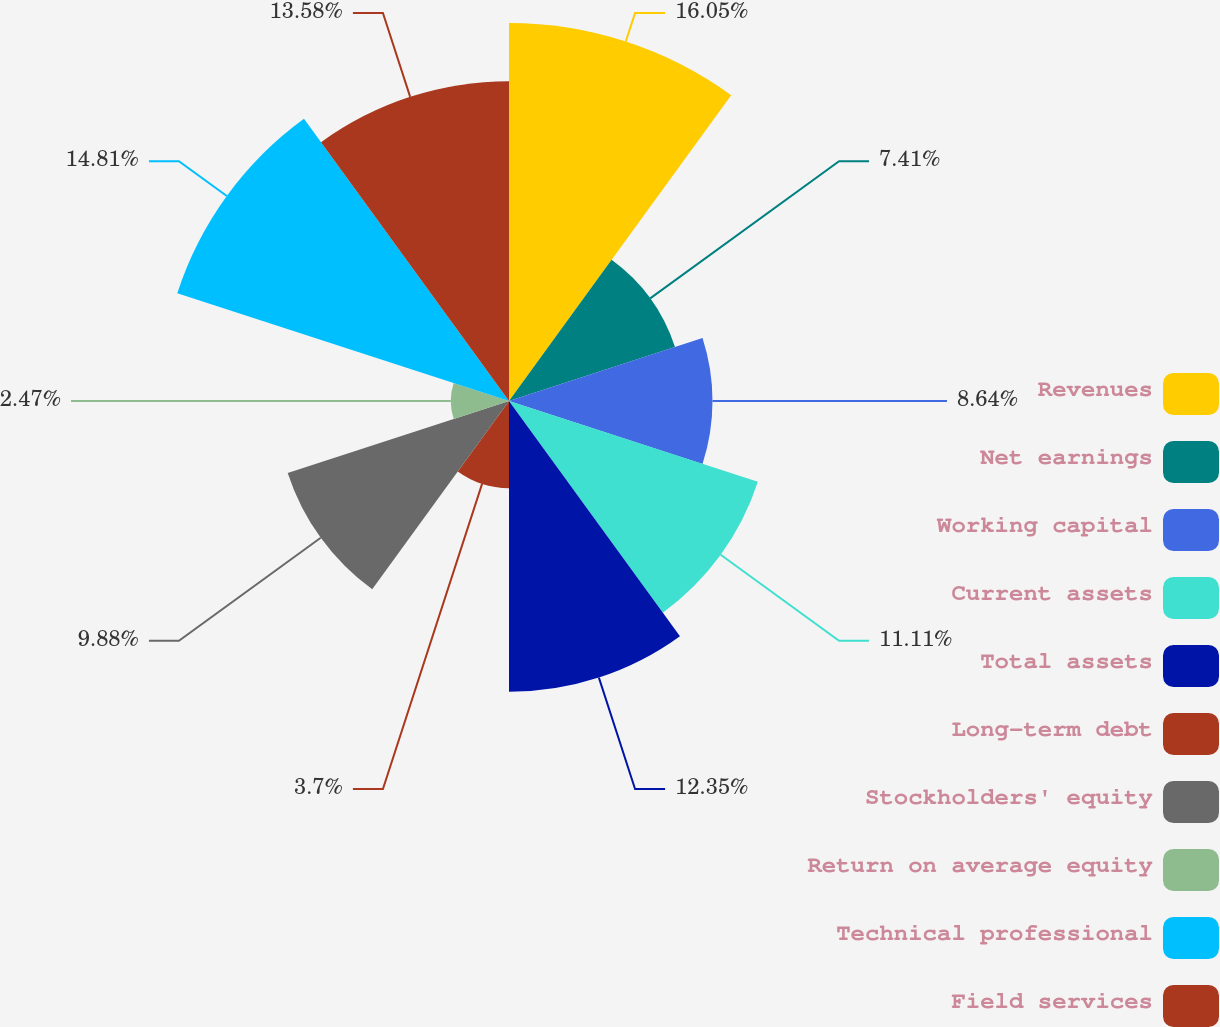Convert chart. <chart><loc_0><loc_0><loc_500><loc_500><pie_chart><fcel>Revenues<fcel>Net earnings<fcel>Working capital<fcel>Current assets<fcel>Total assets<fcel>Long-term debt<fcel>Stockholders' equity<fcel>Return on average equity<fcel>Technical professional<fcel>Field services<nl><fcel>16.05%<fcel>7.41%<fcel>8.64%<fcel>11.11%<fcel>12.35%<fcel>3.7%<fcel>9.88%<fcel>2.47%<fcel>14.81%<fcel>13.58%<nl></chart> 